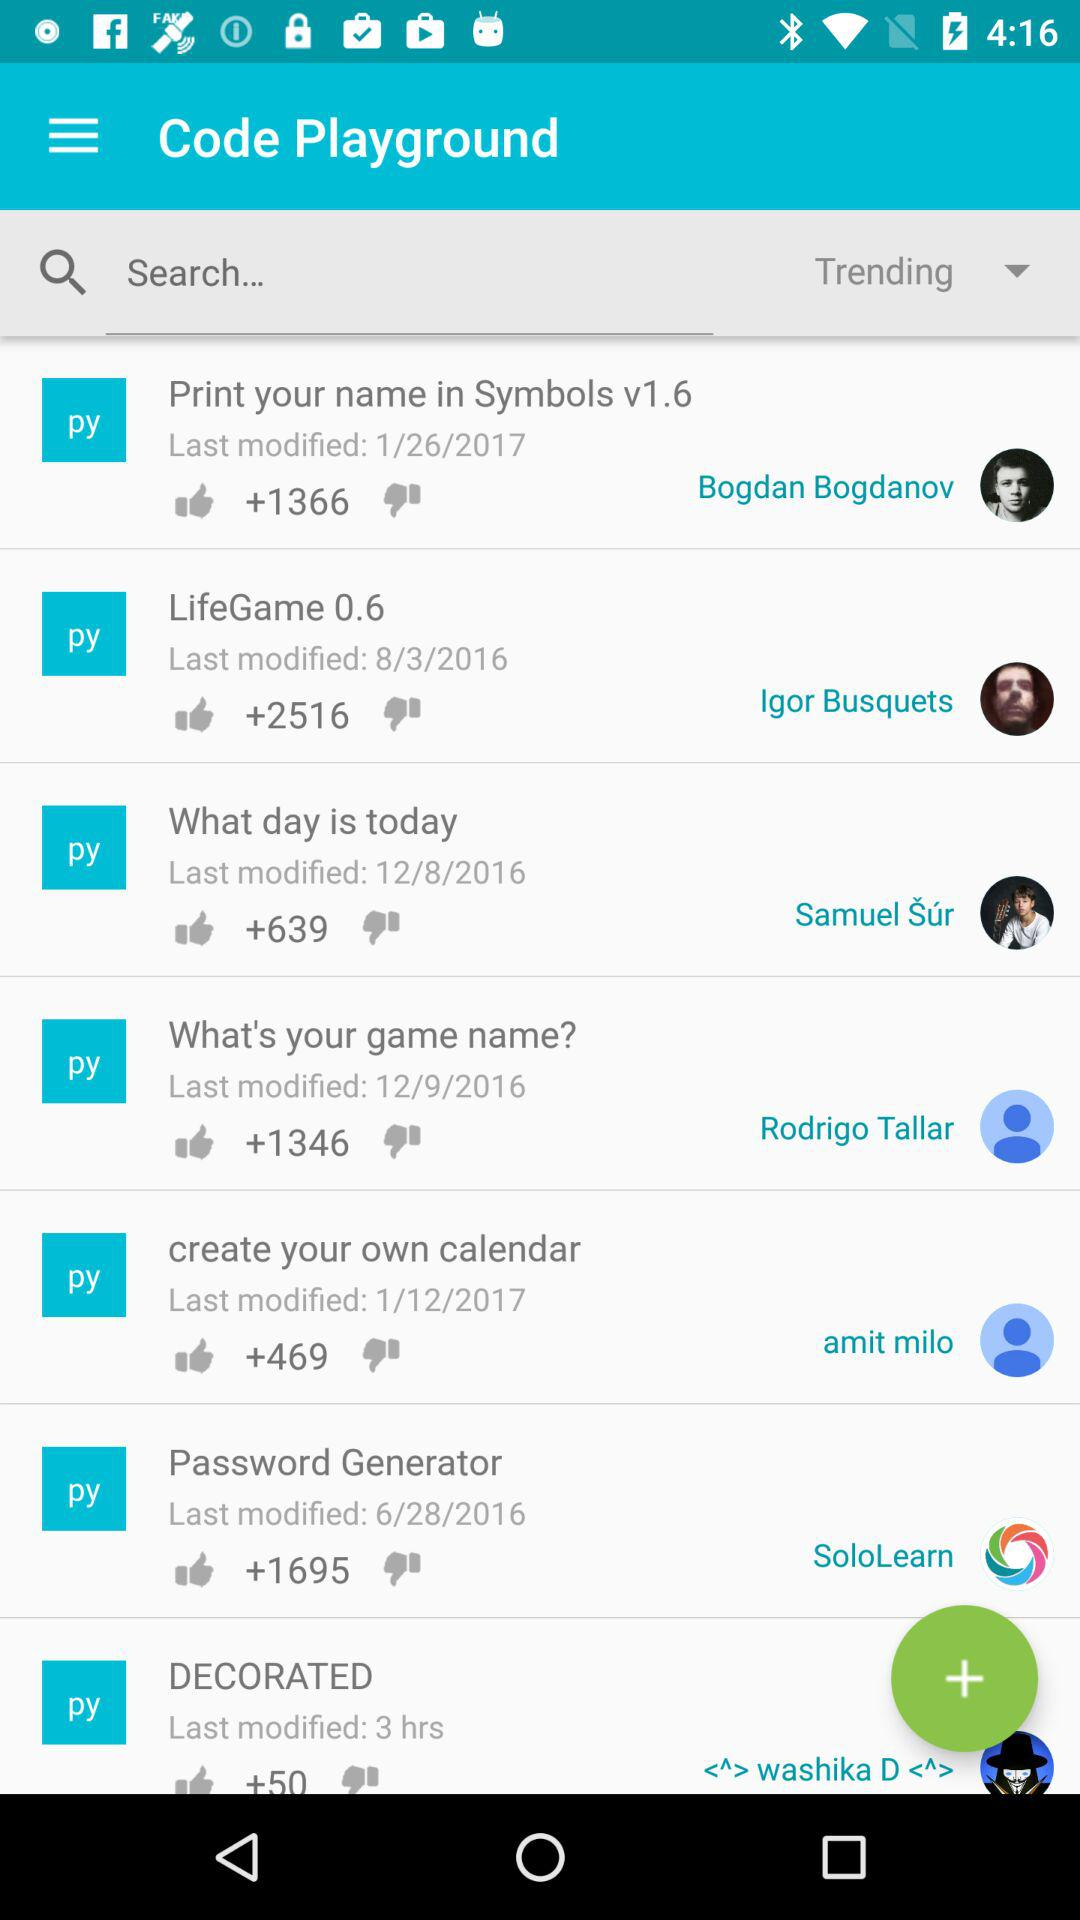How many hours ago was the app with the most recent update last updated?
Answer the question using a single word or phrase. 3 